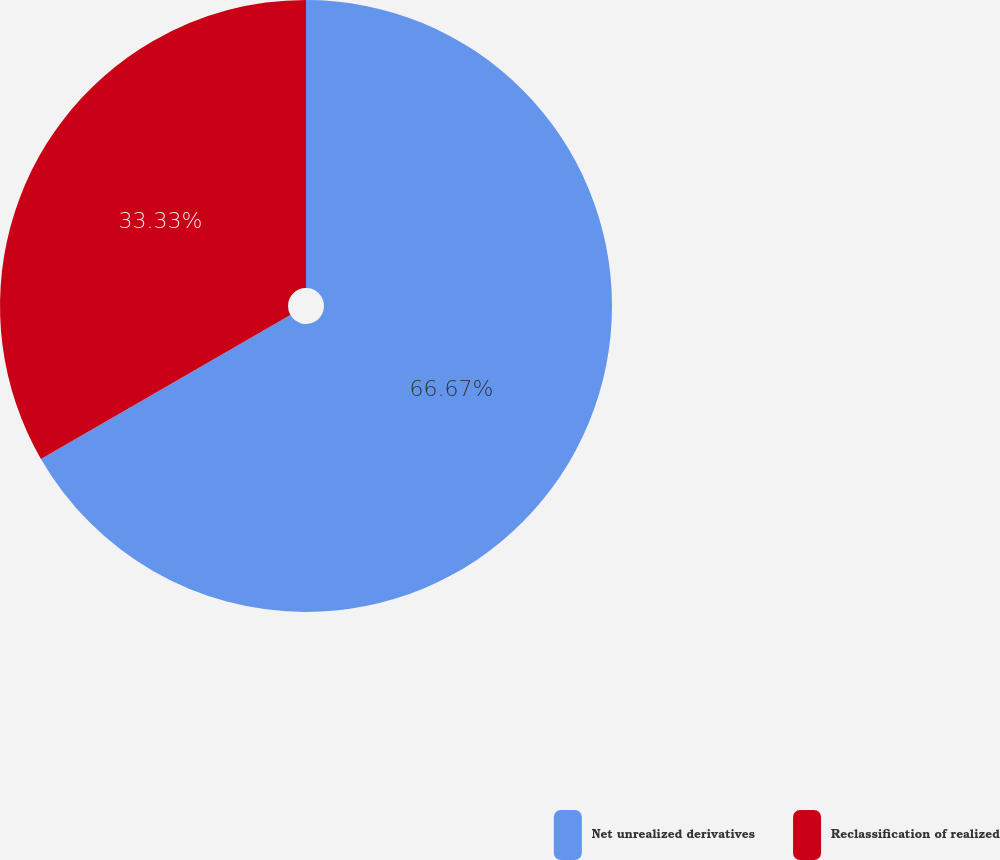Convert chart to OTSL. <chart><loc_0><loc_0><loc_500><loc_500><pie_chart><fcel>Net unrealized derivatives<fcel>Reclassification of realized<nl><fcel>66.67%<fcel>33.33%<nl></chart> 